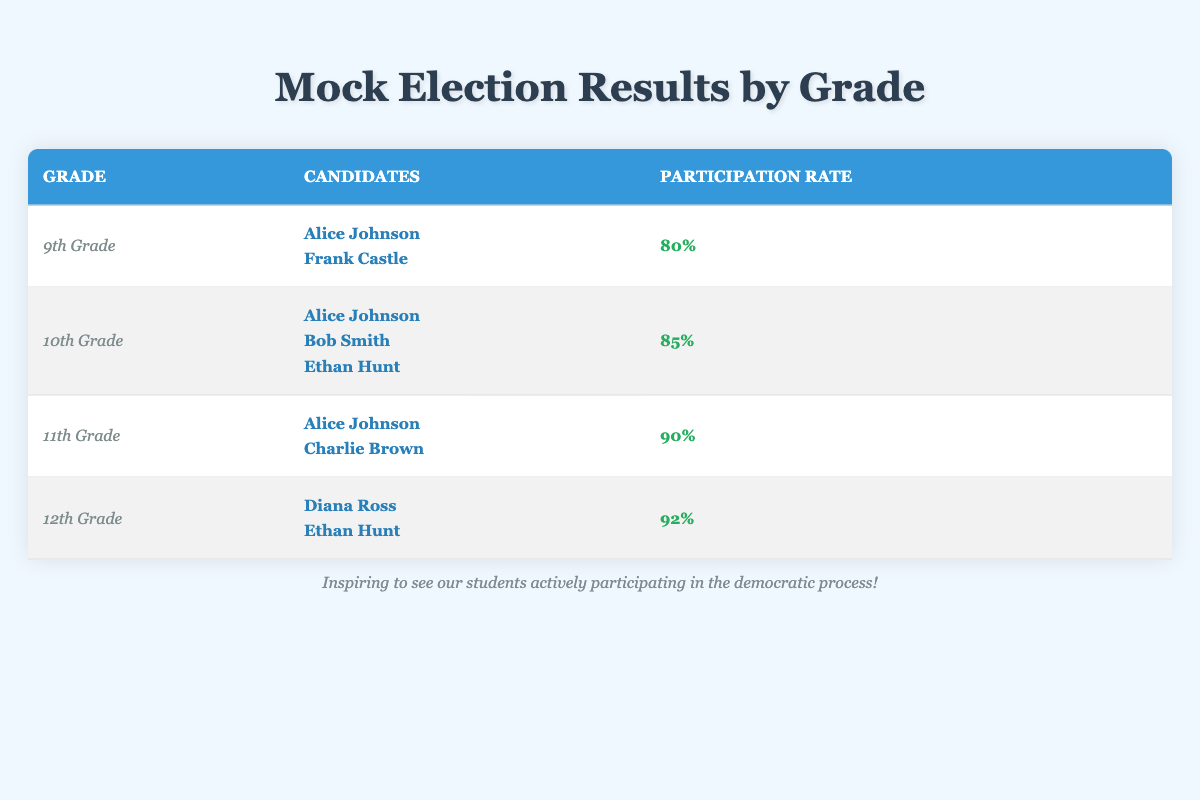What was the participation rate for the 12th Grade candidates? From the table, we can see that the participation rate for the 12th Grade candidates (Diana Ross and Ethan Hunt) is listed as 92%.
Answer: 92% Which candidates ran in the 10th Grade? The table shows that the candidates for the 10th Grade are Alice Johnson, Bob Smith, and Ethan Hunt.
Answer: Alice Johnson, Bob Smith, Ethan Hunt True or False: Frank Castle received a higher participation rate than Alice Johnson in the 9th Grade. In the table, both Frank Castle and Alice Johnson have a participation rate of 80% in the 9th Grade. Since they are equal, the statement is false.
Answer: False What is the average participation rate across all classes? The participation rates from the classes are 80%, 85%, 90%, and 92%. To calculate the average: (80 + 85 + 90 + 92) / 4 = 86.75%.
Answer: 86.75% Which candidate had a participation rate of 90%? Reviewing the table, we find that the candidates with a participation rate of 90% are Alice Johnson and Charlie Brown from the 11th Grade.
Answer: Alice Johnson, Charlie Brown In which grade did candidates have the highest participation rate? By examining the participation rates listed in the table, the highest participation rate is 92%, observed in the 12th Grade candidates.
Answer: 12th Grade What is the difference in participation rates between the 11th and 9th Grades? The participation rate for the 11th Grade is 90%, and for the 9th Grade, it is 80%. To find the difference: 90% - 80% = 10%.
Answer: 10% Which class had the least number of candidates? From the table, the 9th Grade and 12th Grade both had 2 candidates (Alice Johnson and Frank Castle; Diana Ross and Ethan Hunt), which is less than the other grades that have 3 candidates each.
Answer: 9th Grade and 12th Grade Was Bob Smith a candidate in more than one grade? The table indicates that Bob Smith is listed only in the 10th Grade, meaning he was not a candidate in any other grade.
Answer: No 